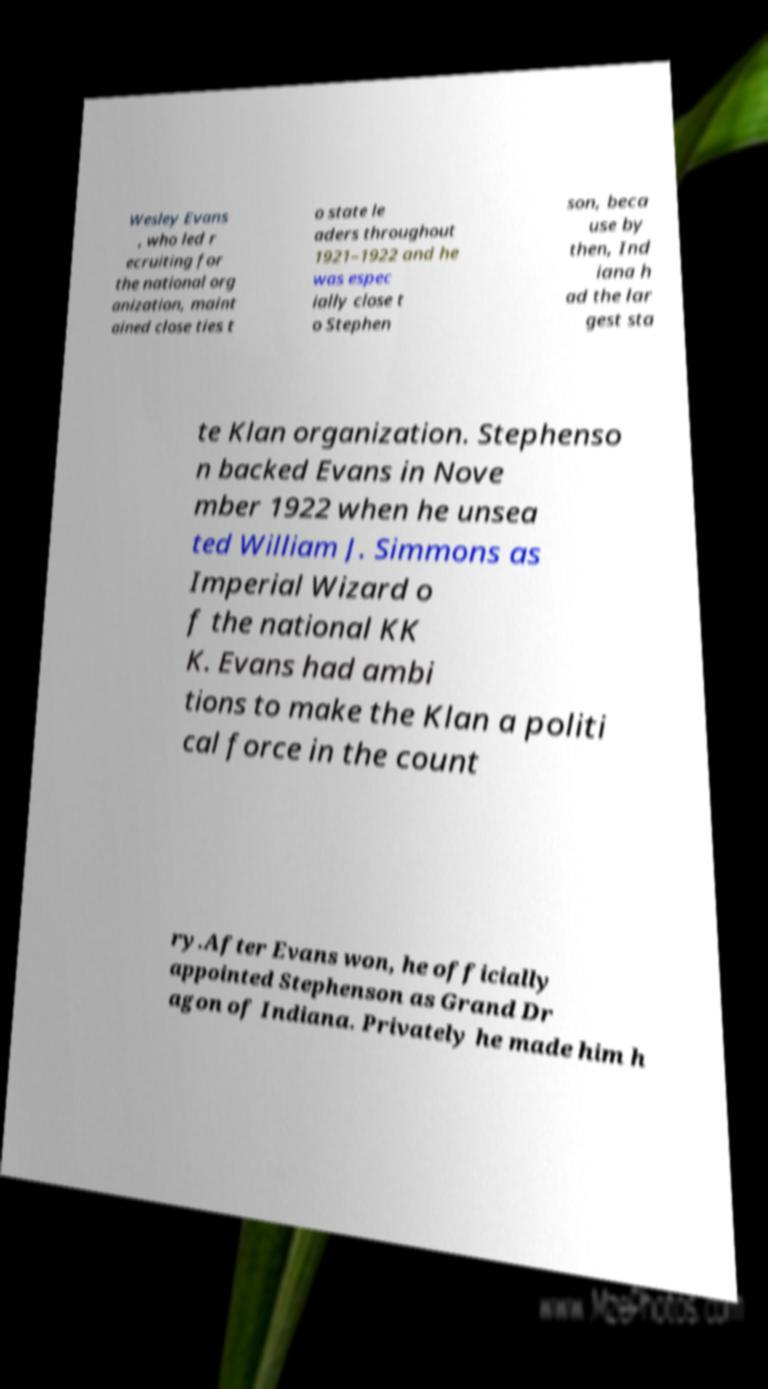I need the written content from this picture converted into text. Can you do that? Wesley Evans , who led r ecruiting for the national org anization, maint ained close ties t o state le aders throughout 1921–1922 and he was espec ially close t o Stephen son, beca use by then, Ind iana h ad the lar gest sta te Klan organization. Stephenso n backed Evans in Nove mber 1922 when he unsea ted William J. Simmons as Imperial Wizard o f the national KK K. Evans had ambi tions to make the Klan a politi cal force in the count ry.After Evans won, he officially appointed Stephenson as Grand Dr agon of Indiana. Privately he made him h 